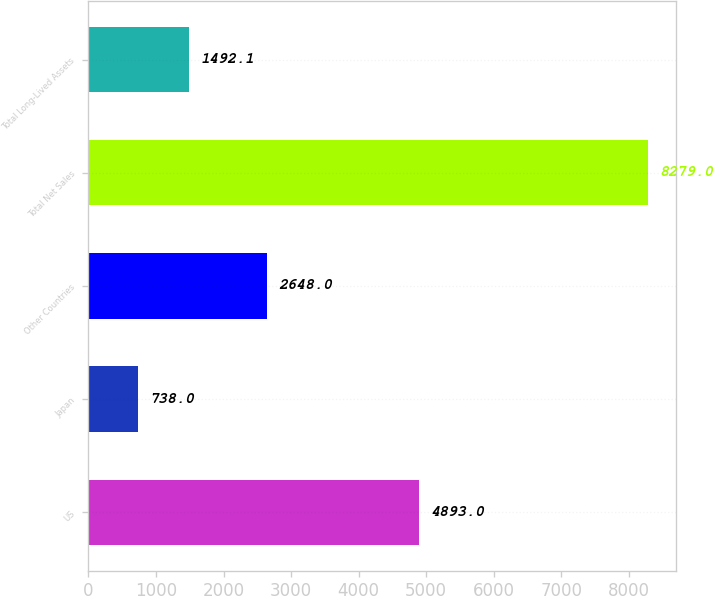Convert chart to OTSL. <chart><loc_0><loc_0><loc_500><loc_500><bar_chart><fcel>US<fcel>Japan<fcel>Other Countries<fcel>Total Net Sales<fcel>Total Long-Lived Assets<nl><fcel>4893<fcel>738<fcel>2648<fcel>8279<fcel>1492.1<nl></chart> 